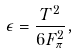Convert formula to latex. <formula><loc_0><loc_0><loc_500><loc_500>\epsilon = \frac { T ^ { 2 } } { 6 F _ { \pi } ^ { 2 } } ,</formula> 